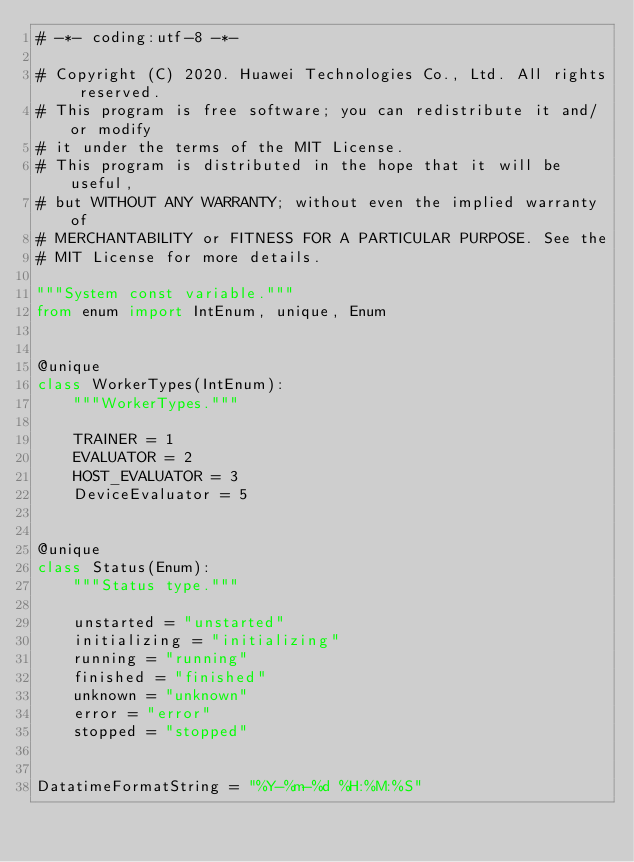Convert code to text. <code><loc_0><loc_0><loc_500><loc_500><_Python_># -*- coding:utf-8 -*-

# Copyright (C) 2020. Huawei Technologies Co., Ltd. All rights reserved.
# This program is free software; you can redistribute it and/or modify
# it under the terms of the MIT License.
# This program is distributed in the hope that it will be useful,
# but WITHOUT ANY WARRANTY; without even the implied warranty of
# MERCHANTABILITY or FITNESS FOR A PARTICULAR PURPOSE. See the
# MIT License for more details.

"""System const variable."""
from enum import IntEnum, unique, Enum


@unique
class WorkerTypes(IntEnum):
    """WorkerTypes."""

    TRAINER = 1
    EVALUATOR = 2
    HOST_EVALUATOR = 3
    DeviceEvaluator = 5


@unique
class Status(Enum):
    """Status type."""

    unstarted = "unstarted"
    initializing = "initializing"
    running = "running"
    finished = "finished"
    unknown = "unknown"
    error = "error"
    stopped = "stopped"


DatatimeFormatString = "%Y-%m-%d %H:%M:%S"
</code> 